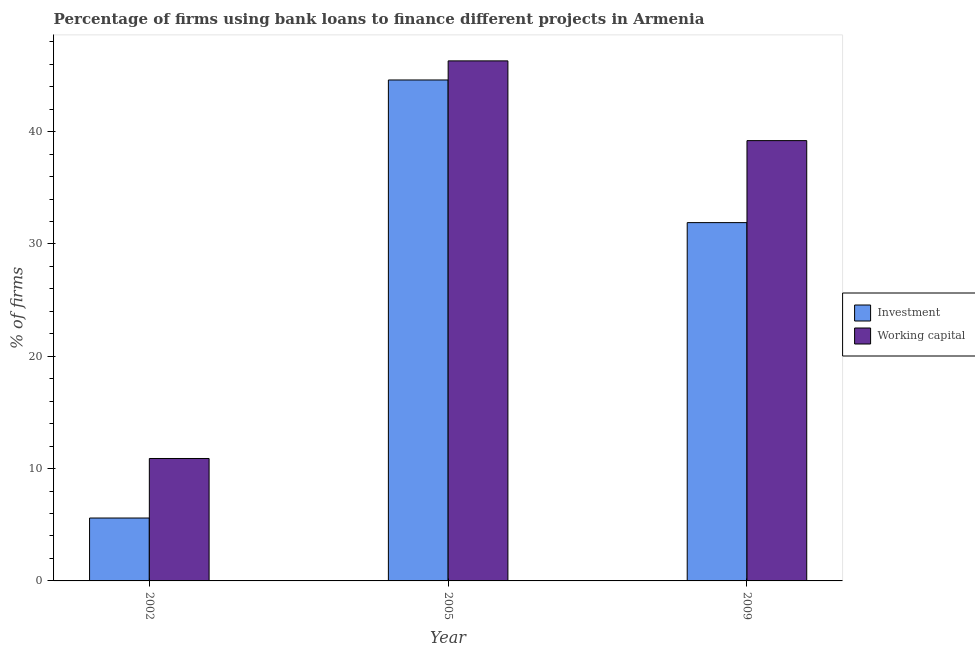How many groups of bars are there?
Your answer should be very brief. 3. Are the number of bars per tick equal to the number of legend labels?
Ensure brevity in your answer.  Yes. How many bars are there on the 1st tick from the right?
Ensure brevity in your answer.  2. In how many cases, is the number of bars for a given year not equal to the number of legend labels?
Provide a succinct answer. 0. What is the percentage of firms using banks to finance working capital in 2005?
Provide a short and direct response. 46.3. Across all years, what is the maximum percentage of firms using banks to finance investment?
Make the answer very short. 44.6. Across all years, what is the minimum percentage of firms using banks to finance investment?
Offer a very short reply. 5.6. In which year was the percentage of firms using banks to finance working capital minimum?
Offer a very short reply. 2002. What is the total percentage of firms using banks to finance working capital in the graph?
Keep it short and to the point. 96.4. What is the difference between the percentage of firms using banks to finance investment in 2002 and that in 2009?
Give a very brief answer. -26.3. What is the difference between the percentage of firms using banks to finance investment in 2005 and the percentage of firms using banks to finance working capital in 2002?
Provide a short and direct response. 39. What is the average percentage of firms using banks to finance investment per year?
Offer a very short reply. 27.37. In how many years, is the percentage of firms using banks to finance investment greater than 8 %?
Ensure brevity in your answer.  2. What is the ratio of the percentage of firms using banks to finance working capital in 2002 to that in 2005?
Ensure brevity in your answer.  0.24. Is the percentage of firms using banks to finance working capital in 2002 less than that in 2009?
Your response must be concise. Yes. What is the difference between the highest and the second highest percentage of firms using banks to finance investment?
Provide a succinct answer. 12.7. In how many years, is the percentage of firms using banks to finance working capital greater than the average percentage of firms using banks to finance working capital taken over all years?
Offer a terse response. 2. What does the 2nd bar from the left in 2009 represents?
Offer a terse response. Working capital. What does the 1st bar from the right in 2002 represents?
Provide a short and direct response. Working capital. Are all the bars in the graph horizontal?
Make the answer very short. No. How many years are there in the graph?
Your response must be concise. 3. What is the difference between two consecutive major ticks on the Y-axis?
Your answer should be compact. 10. Are the values on the major ticks of Y-axis written in scientific E-notation?
Offer a terse response. No. What is the title of the graph?
Provide a succinct answer. Percentage of firms using bank loans to finance different projects in Armenia. Does "Non-resident workers" appear as one of the legend labels in the graph?
Your response must be concise. No. What is the label or title of the Y-axis?
Make the answer very short. % of firms. What is the % of firms of Investment in 2002?
Give a very brief answer. 5.6. What is the % of firms in Working capital in 2002?
Ensure brevity in your answer.  10.9. What is the % of firms in Investment in 2005?
Provide a short and direct response. 44.6. What is the % of firms of Working capital in 2005?
Keep it short and to the point. 46.3. What is the % of firms of Investment in 2009?
Make the answer very short. 31.9. What is the % of firms in Working capital in 2009?
Give a very brief answer. 39.2. Across all years, what is the maximum % of firms in Investment?
Keep it short and to the point. 44.6. Across all years, what is the maximum % of firms of Working capital?
Keep it short and to the point. 46.3. Across all years, what is the minimum % of firms in Investment?
Give a very brief answer. 5.6. What is the total % of firms in Investment in the graph?
Your answer should be compact. 82.1. What is the total % of firms of Working capital in the graph?
Ensure brevity in your answer.  96.4. What is the difference between the % of firms of Investment in 2002 and that in 2005?
Offer a very short reply. -39. What is the difference between the % of firms of Working capital in 2002 and that in 2005?
Your answer should be compact. -35.4. What is the difference between the % of firms of Investment in 2002 and that in 2009?
Provide a short and direct response. -26.3. What is the difference between the % of firms in Working capital in 2002 and that in 2009?
Keep it short and to the point. -28.3. What is the difference between the % of firms of Investment in 2002 and the % of firms of Working capital in 2005?
Provide a succinct answer. -40.7. What is the difference between the % of firms in Investment in 2002 and the % of firms in Working capital in 2009?
Your response must be concise. -33.6. What is the difference between the % of firms of Investment in 2005 and the % of firms of Working capital in 2009?
Give a very brief answer. 5.4. What is the average % of firms in Investment per year?
Provide a succinct answer. 27.37. What is the average % of firms of Working capital per year?
Provide a succinct answer. 32.13. In the year 2002, what is the difference between the % of firms of Investment and % of firms of Working capital?
Offer a very short reply. -5.3. What is the ratio of the % of firms in Investment in 2002 to that in 2005?
Your answer should be very brief. 0.13. What is the ratio of the % of firms in Working capital in 2002 to that in 2005?
Provide a short and direct response. 0.24. What is the ratio of the % of firms in Investment in 2002 to that in 2009?
Ensure brevity in your answer.  0.18. What is the ratio of the % of firms of Working capital in 2002 to that in 2009?
Provide a short and direct response. 0.28. What is the ratio of the % of firms of Investment in 2005 to that in 2009?
Provide a succinct answer. 1.4. What is the ratio of the % of firms of Working capital in 2005 to that in 2009?
Your answer should be compact. 1.18. What is the difference between the highest and the second highest % of firms in Investment?
Your answer should be compact. 12.7. What is the difference between the highest and the second highest % of firms of Working capital?
Provide a succinct answer. 7.1. What is the difference between the highest and the lowest % of firms in Investment?
Your answer should be compact. 39. What is the difference between the highest and the lowest % of firms in Working capital?
Make the answer very short. 35.4. 